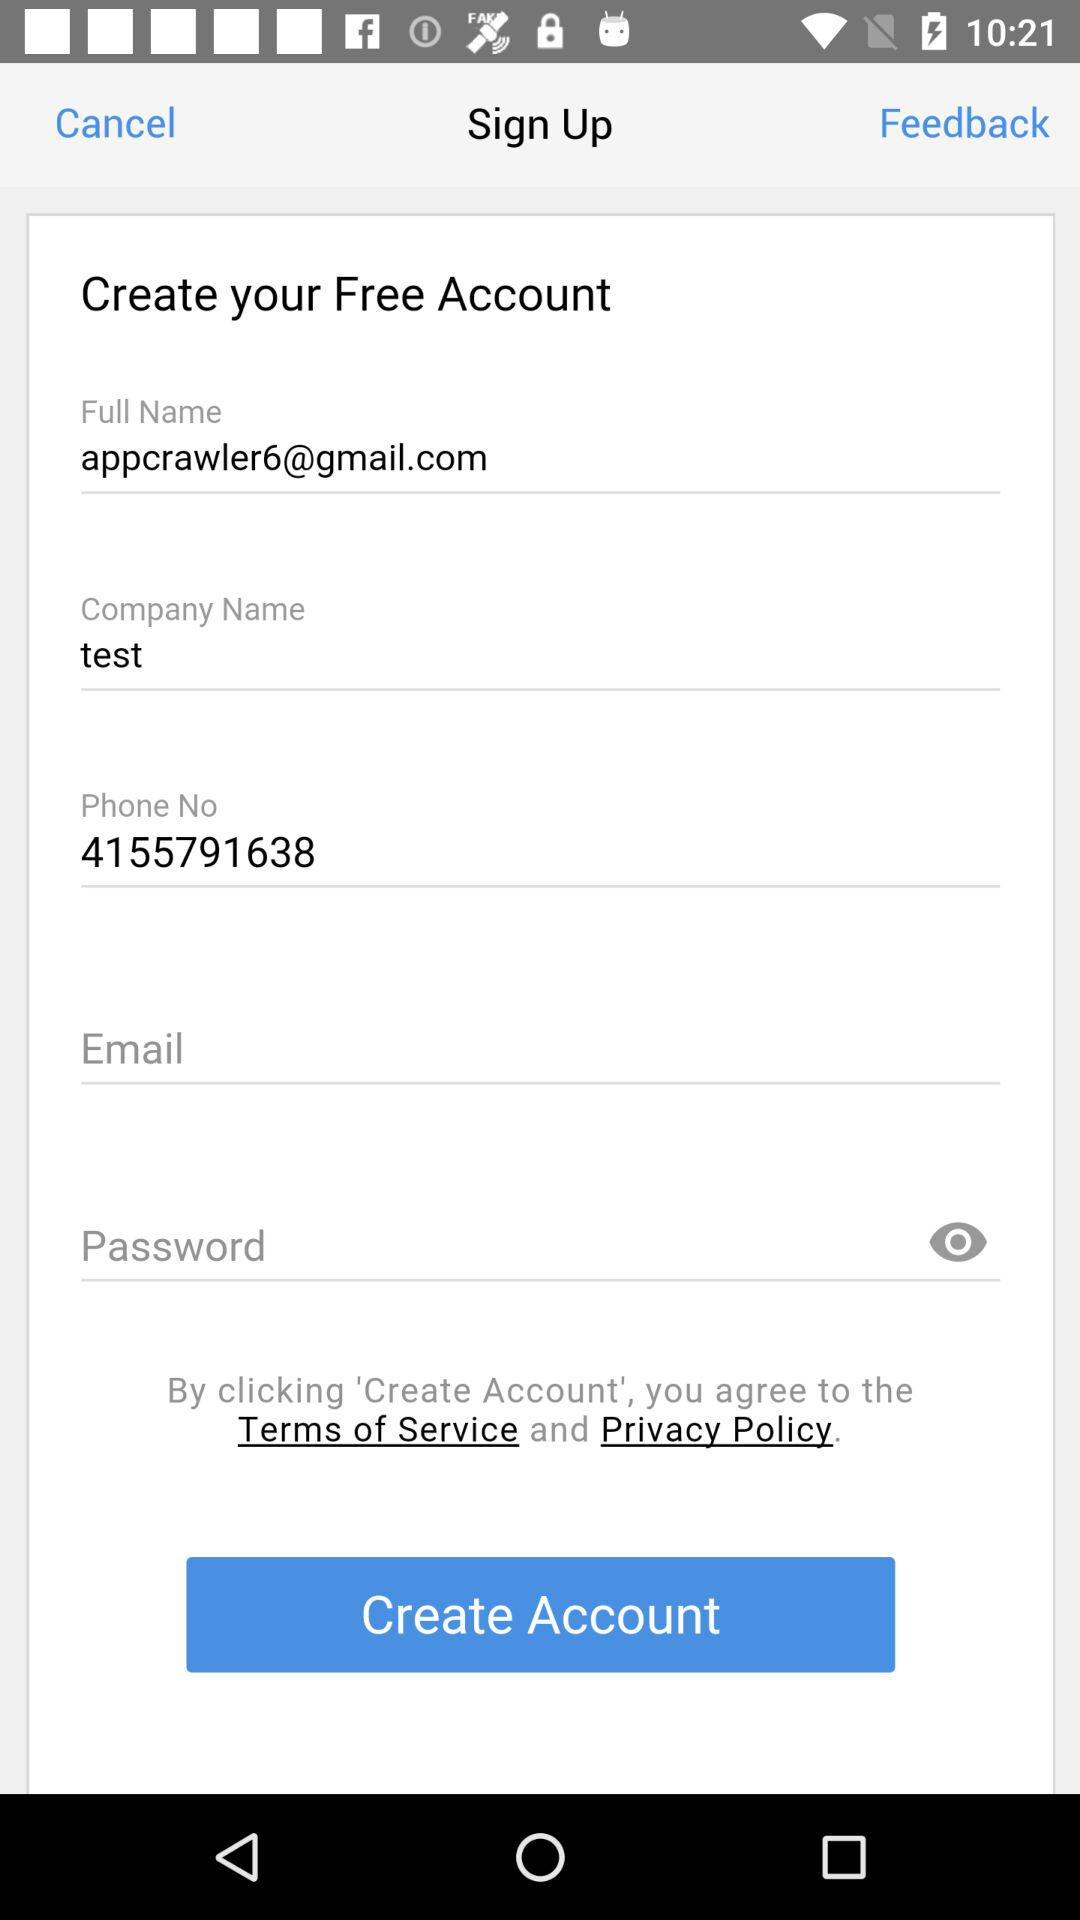What is the company name? The company name is "test". 